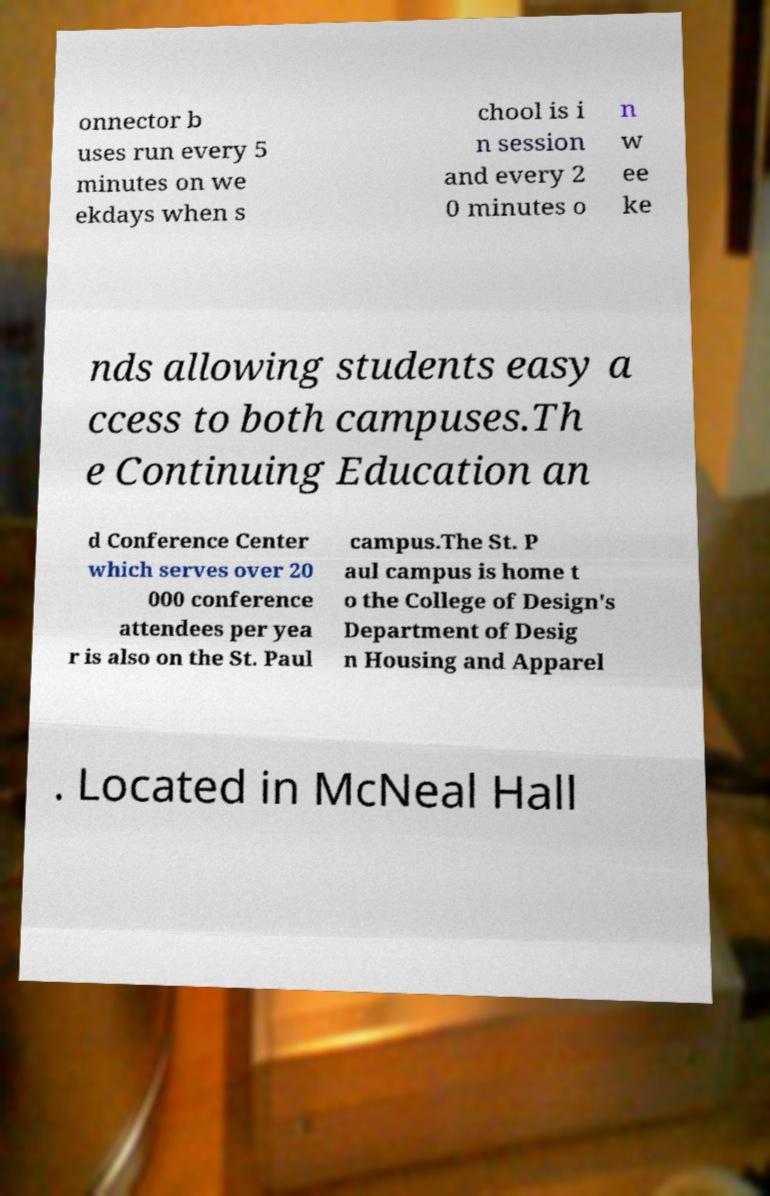For documentation purposes, I need the text within this image transcribed. Could you provide that? onnector b uses run every 5 minutes on we ekdays when s chool is i n session and every 2 0 minutes o n w ee ke nds allowing students easy a ccess to both campuses.Th e Continuing Education an d Conference Center which serves over 20 000 conference attendees per yea r is also on the St. Paul campus.The St. P aul campus is home t o the College of Design's Department of Desig n Housing and Apparel . Located in McNeal Hall 